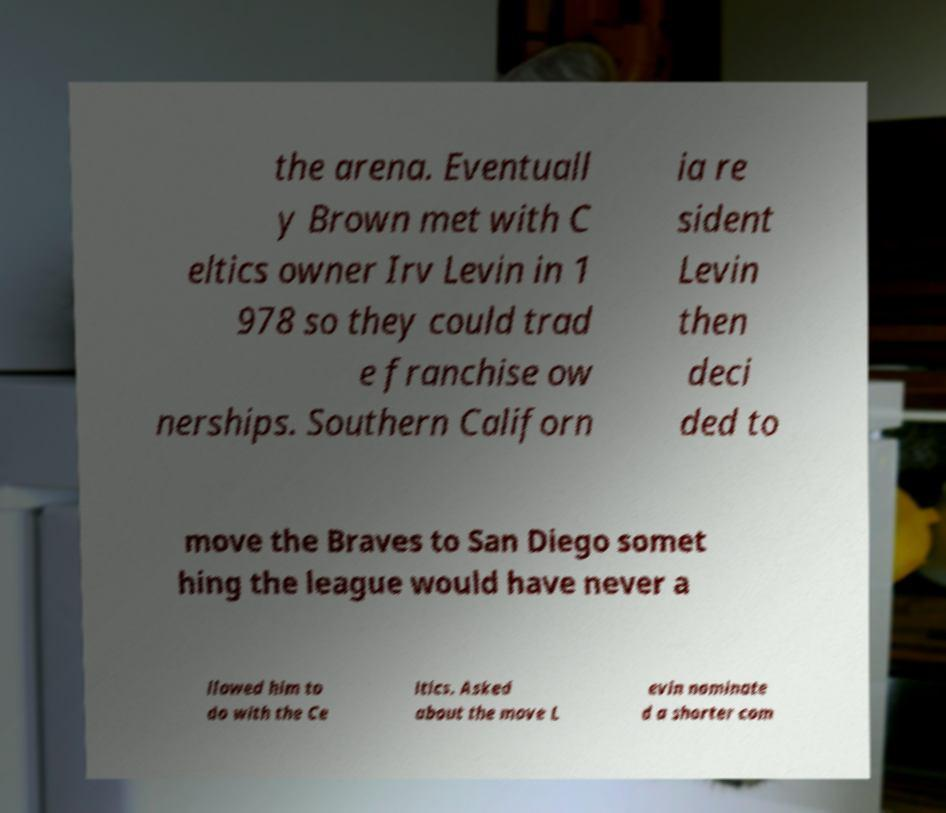I need the written content from this picture converted into text. Can you do that? the arena. Eventuall y Brown met with C eltics owner Irv Levin in 1 978 so they could trad e franchise ow nerships. Southern Californ ia re sident Levin then deci ded to move the Braves to San Diego somet hing the league would have never a llowed him to do with the Ce ltics. Asked about the move L evin nominate d a shorter com 